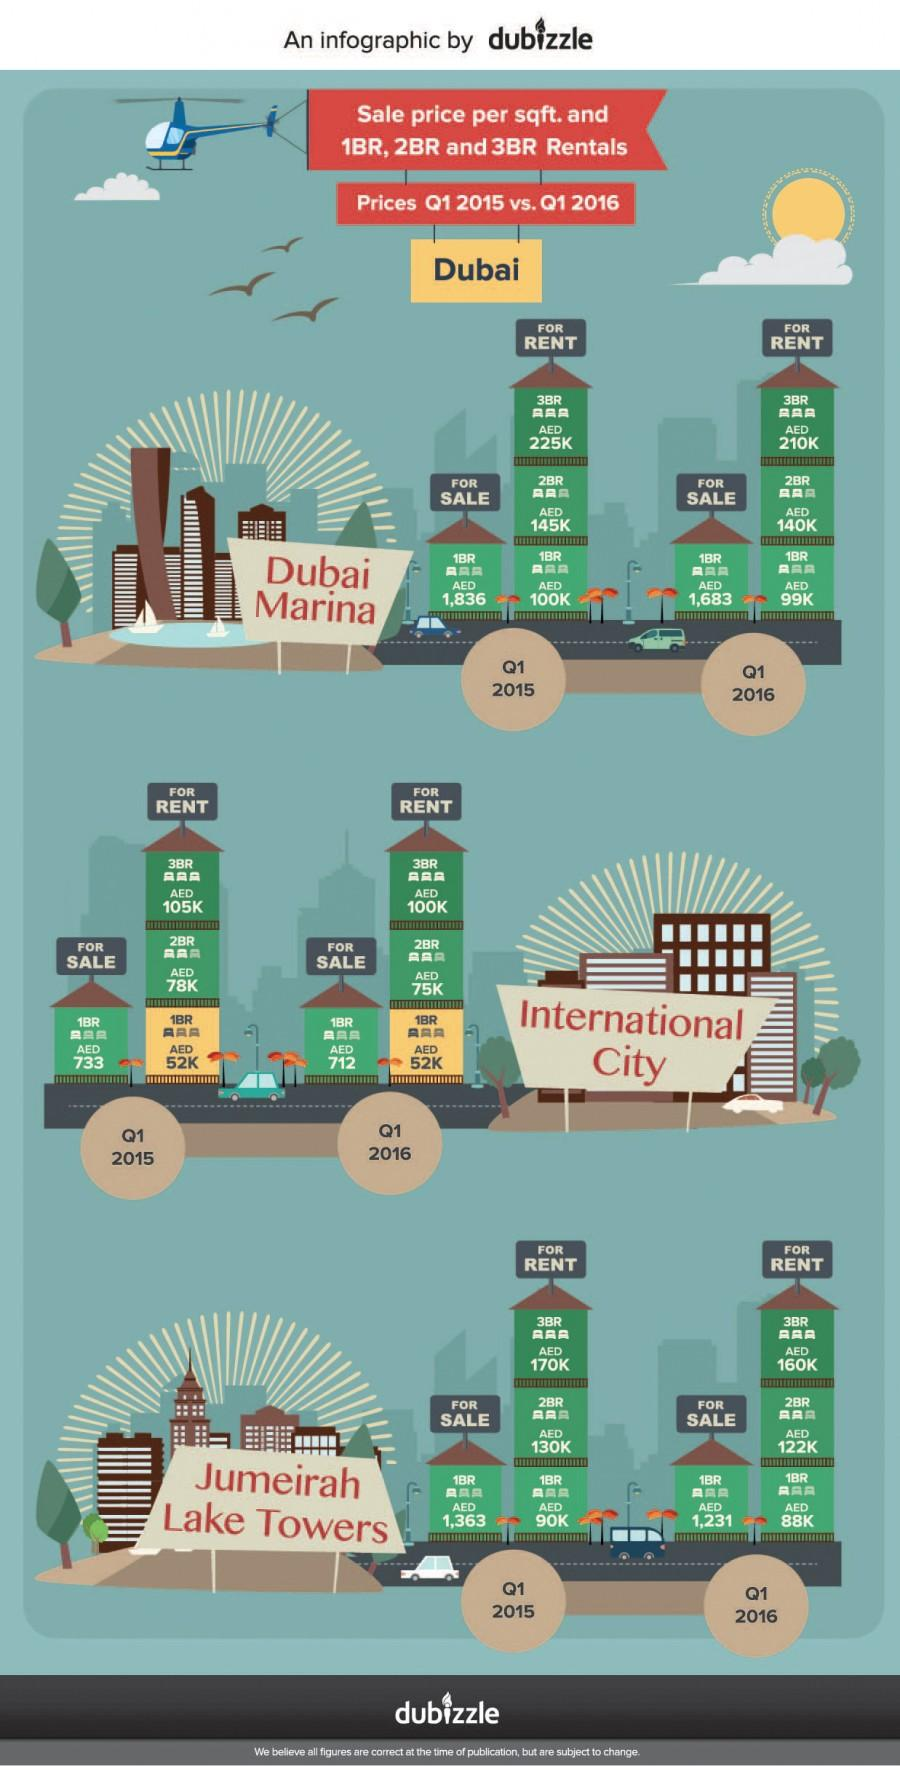Highlight a few significant elements in this photo. The rental rate of a 3-bedroom flat in Dubai Marina during the first quarter of 2016 was AED 210,000. As of the first quarter of 2016, the rental rate for a one-bedroom flat in Dubai Marina was approximately AED 99,000. In the first quarter of 2016, the rental rate for a 3 bedroom flat in Dubai International City was AED 100,000. The rental rate for a 1 bedroom flat in the first quarter of 2015 in Dubai International City was approximately 52,000 AED. The rent (AED) for a 1 and 2 Bed Room flat taken together in Jumeirah Lake Towers for the first quarter of 2015 was approximately 220. 